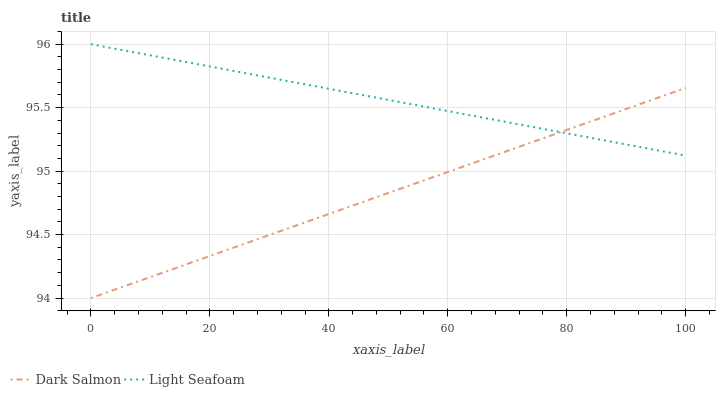Does Dark Salmon have the minimum area under the curve?
Answer yes or no. Yes. Does Light Seafoam have the maximum area under the curve?
Answer yes or no. Yes. Does Dark Salmon have the maximum area under the curve?
Answer yes or no. No. Is Dark Salmon the smoothest?
Answer yes or no. Yes. Is Light Seafoam the roughest?
Answer yes or no. Yes. Is Dark Salmon the roughest?
Answer yes or no. No. Does Dark Salmon have the lowest value?
Answer yes or no. Yes. Does Light Seafoam have the highest value?
Answer yes or no. Yes. Does Dark Salmon have the highest value?
Answer yes or no. No. Does Light Seafoam intersect Dark Salmon?
Answer yes or no. Yes. Is Light Seafoam less than Dark Salmon?
Answer yes or no. No. Is Light Seafoam greater than Dark Salmon?
Answer yes or no. No. 